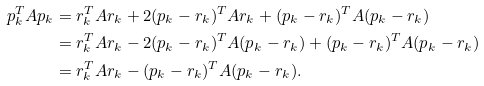<formula> <loc_0><loc_0><loc_500><loc_500>p _ { k } ^ { T } A p _ { k } & = r _ { k } ^ { T } A r _ { k } + 2 ( p _ { k } - r _ { k } ) ^ { T } A r _ { k } + ( p _ { k } - r _ { k } ) ^ { T } A ( p _ { k } - r _ { k } ) \\ & = r _ { k } ^ { T } A r _ { k } - 2 ( p _ { k } - r _ { k } ) ^ { T } A ( p _ { k } - r _ { k } ) + ( p _ { k } - r _ { k } ) ^ { T } A ( p _ { k } - r _ { k } ) \\ & = r _ { k } ^ { T } A r _ { k } - ( p _ { k } - r _ { k } ) ^ { T } A ( p _ { k } - r _ { k } ) .</formula> 